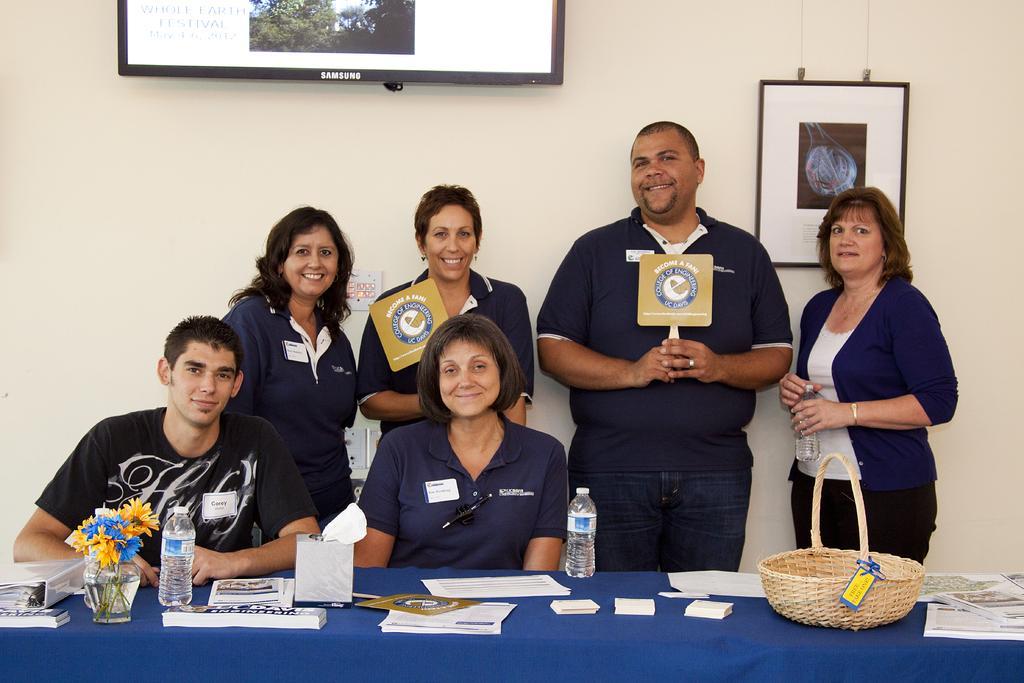Can you describe this image briefly? This picture describes about group of people, few people are seated and few are standing, in front of them we can see few bottles, papers, books, flower vase and a tub on the table, behind them we can see a wall painting and television on the wall. 